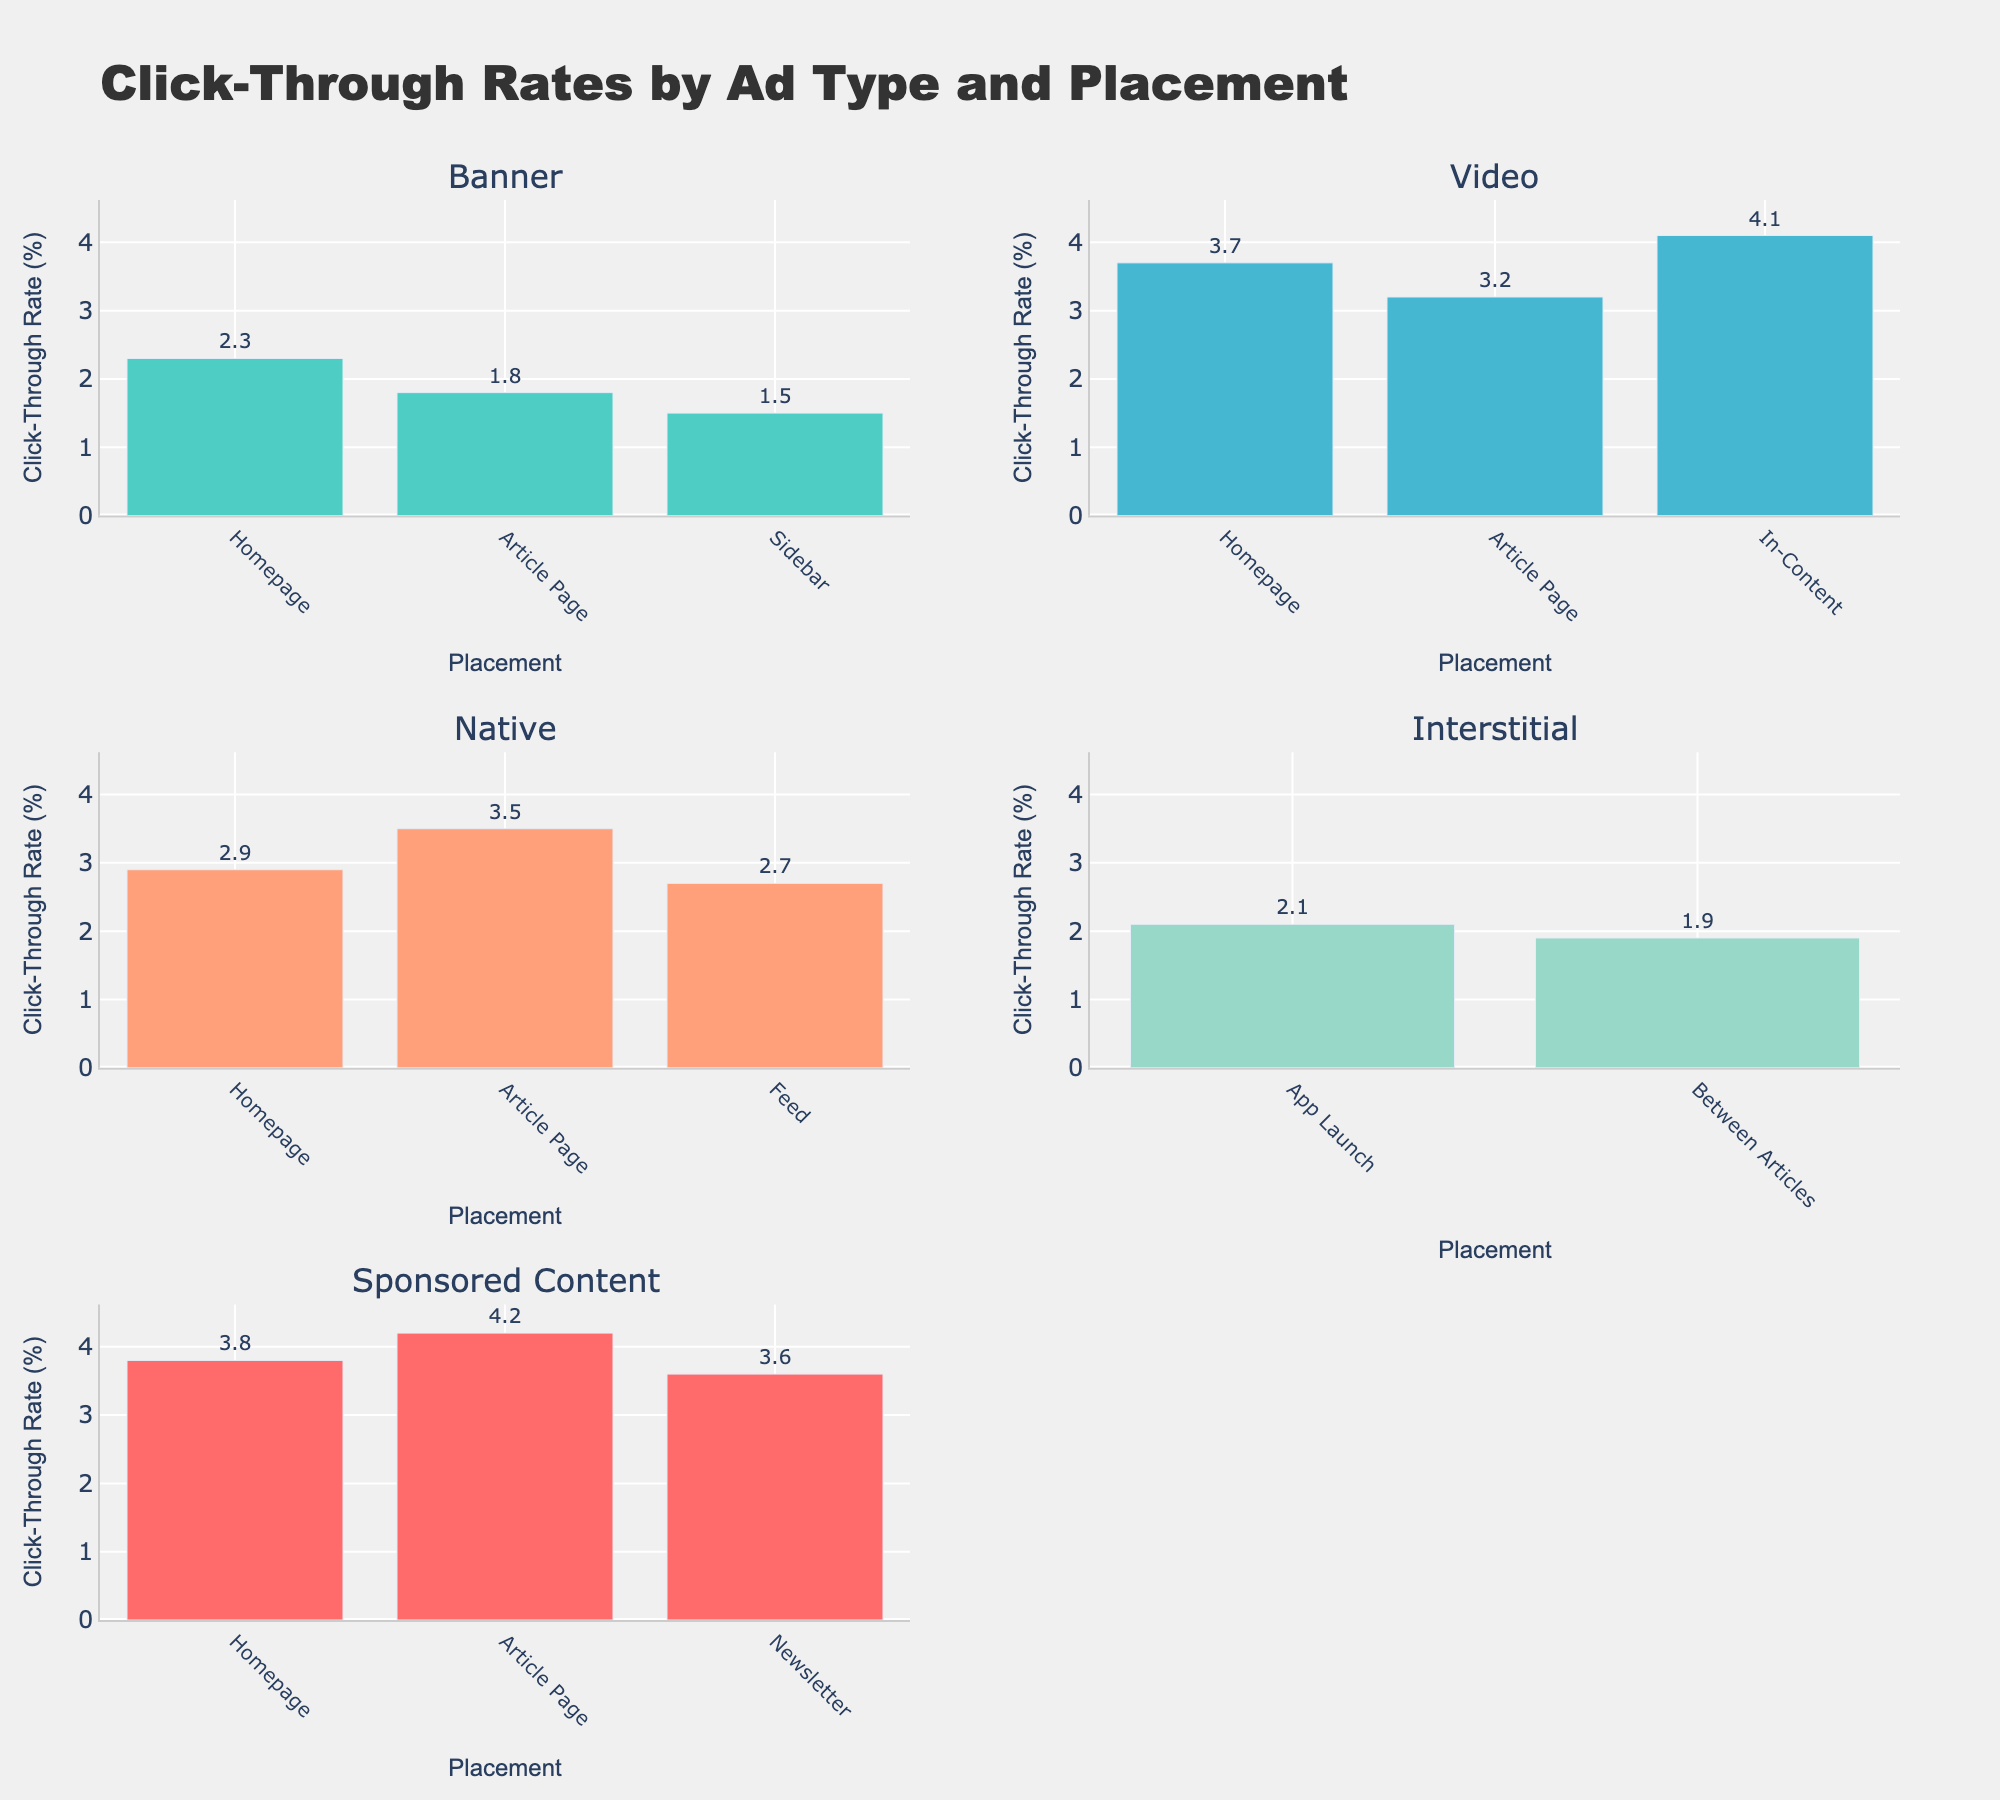How many placement locations are there for Banner ads? Look at the subplot for Banner ads and count the number of distinct bars representing different placements.
Answer: 3 Which ad type has the highest click-through rate (CTR) and what is the value? Identify the bar with the maximum height across all subplots. The highest is for Video ads in the In-Content placement.
Answer: Video, 4.1% What's the difference in CTR between Sponsored Content on the Homepage and in the Newsletter? Sponsored Content home page has a CTR of 3.8, and Newsletter has 3.6. Subtract the smaller from the larger to find the difference.
Answer: 0.2% Which placement type has the lowest CTR for Interstitial ads? Look at the bars for Interstitial ads and identify the shortest one.
Answer: Between Articles What is the average CTR for Native ads across all placement locations? Sum the CTR values for all Native placements (Homepage: 2.9, Article Page: 3.5, Feed: 2.7) and divide by the number of placements. Calculation: (2.9 + 3.5 + 2.7) / 3 = 9.1 / 3 = 3.03
Answer: 3.03 How does the CTR of Video ads on the Article Page compare to Banner ads on the same page? Find the heights of the corresponding bars. Video on Article Page is 3.2 and Banner on Article Page is 1.8; Video is higher.
Answer: Higher What is the median CTR for all Sponsored Content placements? List the CTR values for Sponsored Content (Homepage: 3.8, Article Page: 4.2, Newsletter: 3.6), order them (3.6, 3.8, 4.2), and find the middle value.
Answer: 3.8 What is the sum of CTR values for all placements of Banner ads? Sum the CTR values for all Banner placements (Homepage: 2.3, Article Page: 1.8, Sidebar: 1.5). Calculation: 2.3 + 1.8 + 1.5 = 5.6
Answer: 5.6 How many data points are there in the subplot for Native ads? Count the number of bars in the Native ads subplot.
Answer: 3 